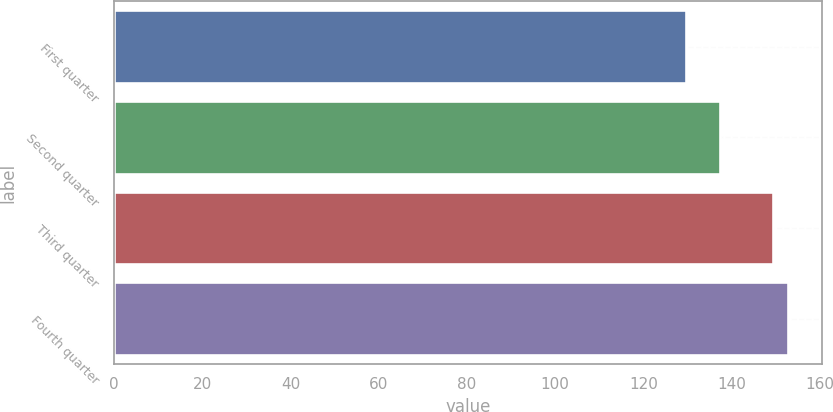Convert chart to OTSL. <chart><loc_0><loc_0><loc_500><loc_500><bar_chart><fcel>First quarter<fcel>Second quarter<fcel>Third quarter<fcel>Fourth quarter<nl><fcel>129.62<fcel>137.29<fcel>149.28<fcel>152.83<nl></chart> 